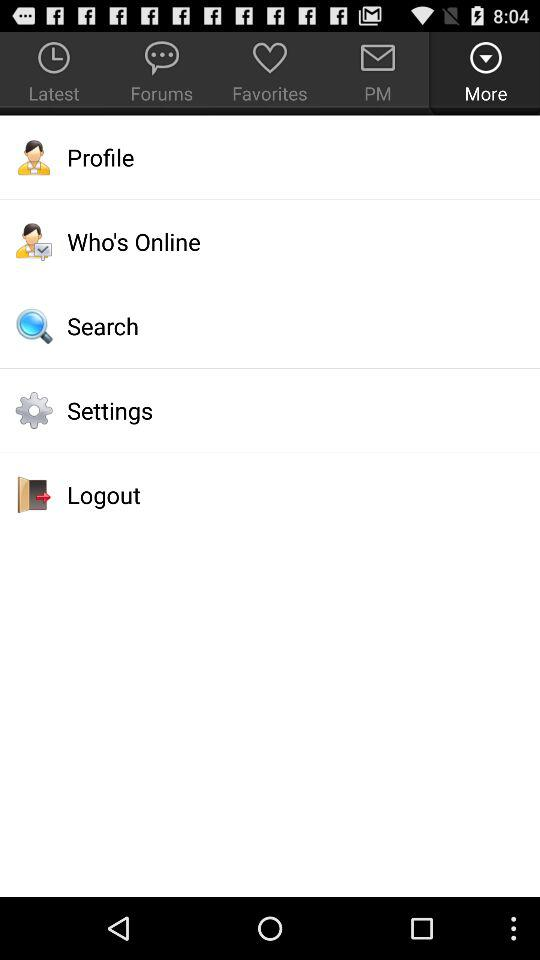Which tab am I using? You are using the "More" tab. 